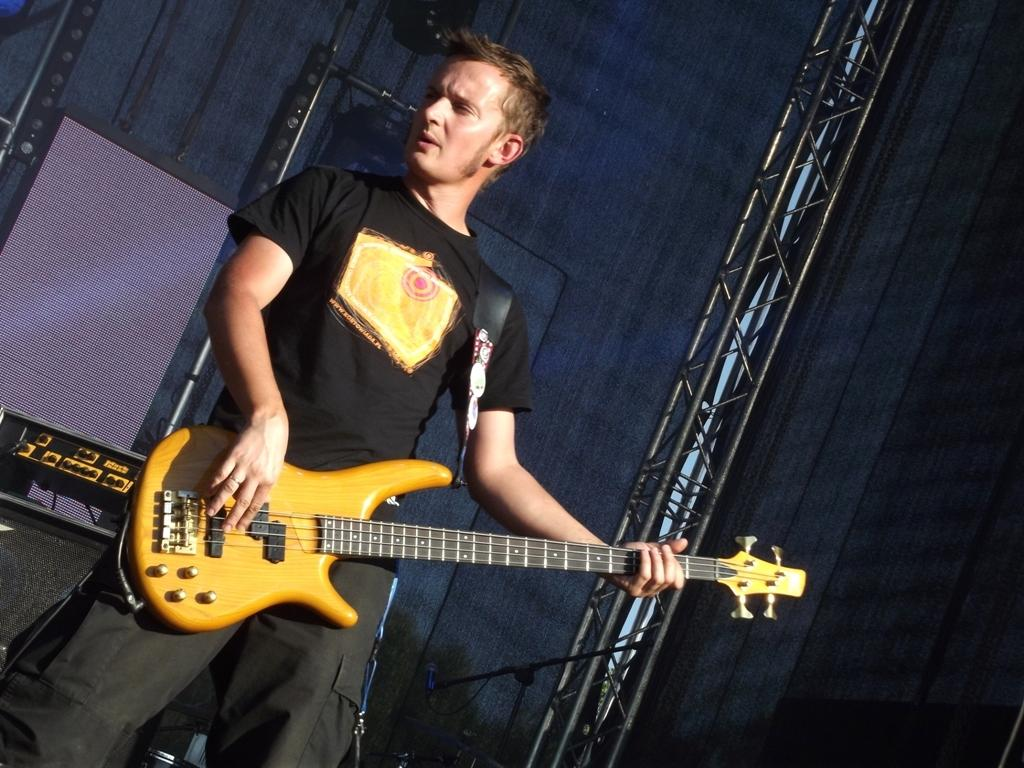What is the man in the image doing? The man is playing the guitar and singing. What is the man wearing in the image? The man is wearing a black t-shirt. What instrument is the man holding in the image? The man is holding a guitar. What can be seen in the background of the image? There is a blue wall, a stage, and other materials visible in the background. How many cherries are on the man's guitar in the image? There are no cherries present on the man's guitar in the image. What type of minister is standing next to the man in the image? There is no minister present in the image. 